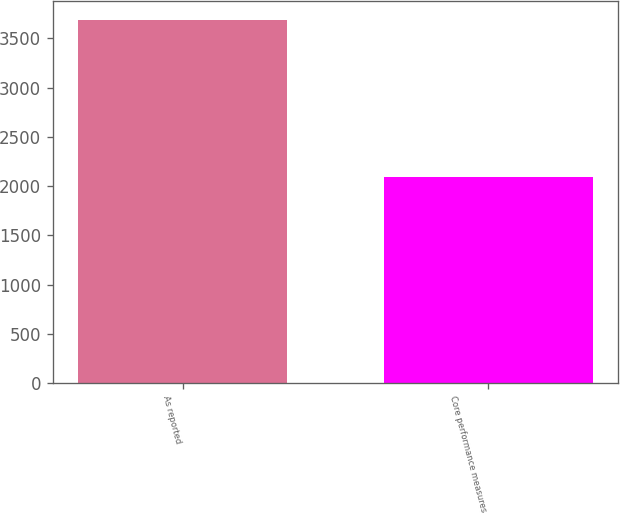<chart> <loc_0><loc_0><loc_500><loc_500><bar_chart><fcel>As reported<fcel>Core performance measures<nl><fcel>3692<fcel>2096<nl></chart> 